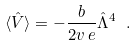<formula> <loc_0><loc_0><loc_500><loc_500>\langle \hat { V } \rangle = - \frac { b } { 2 v \, e } \hat { \Lambda } ^ { 4 } \ .</formula> 